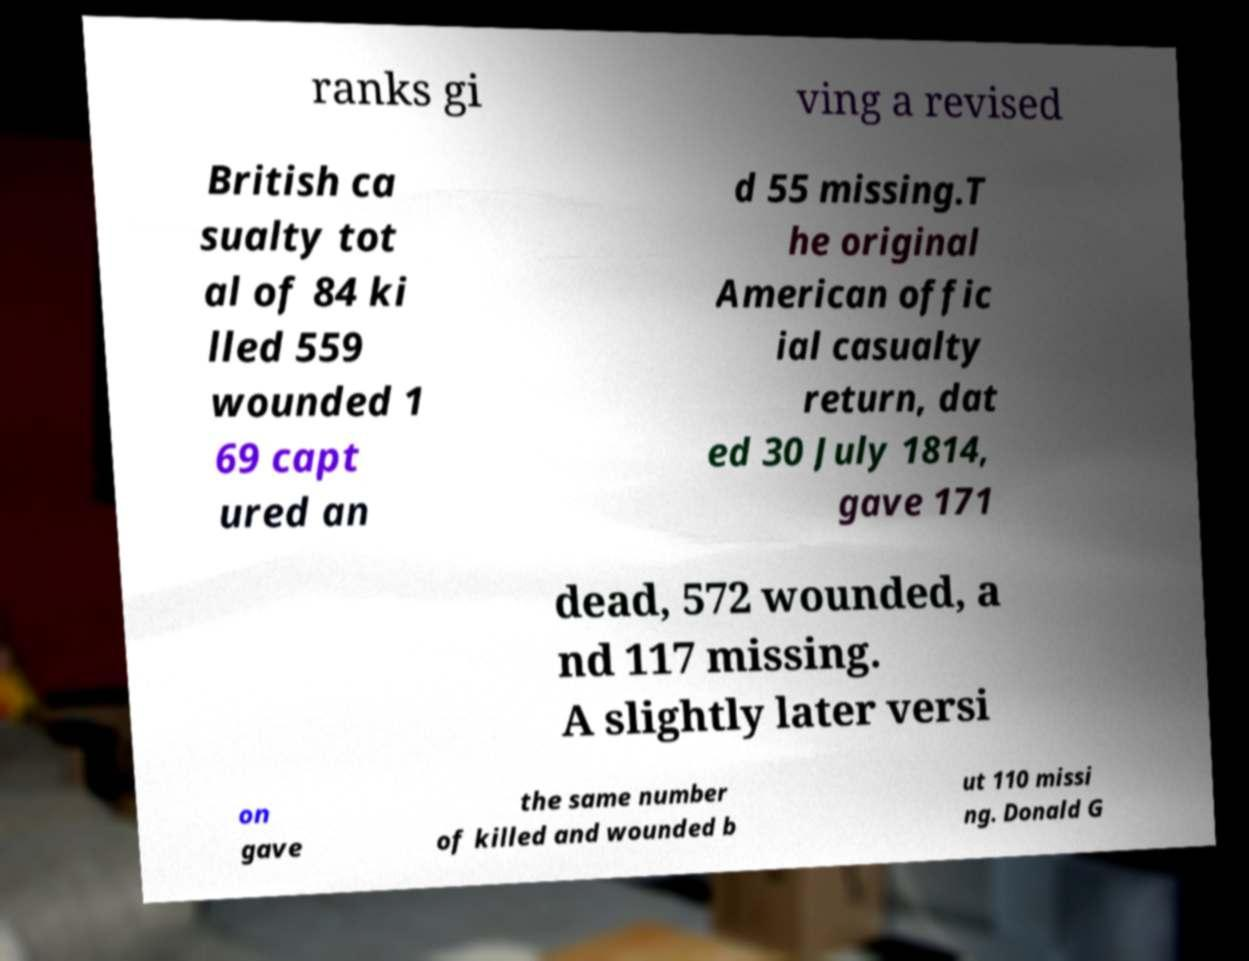Please read and relay the text visible in this image. What does it say? ranks gi ving a revised British ca sualty tot al of 84 ki lled 559 wounded 1 69 capt ured an d 55 missing.T he original American offic ial casualty return, dat ed 30 July 1814, gave 171 dead, 572 wounded, a nd 117 missing. A slightly later versi on gave the same number of killed and wounded b ut 110 missi ng. Donald G 